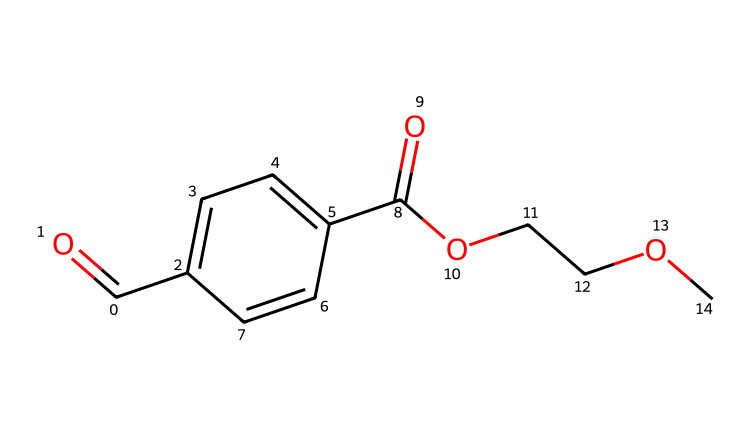What is the main functional group present in this structure? The structure contains ester groups (–COO–), which are characterized by the presence of a carbonyl group (C=O) adjacent to an ether oxygen (–O–). This is indicated by the pattern of C(=O) connected to O in the molecular structure.
Answer: ester How many carbon atoms are in the chemical structure? By analyzing the SMILES representation, we can count the number of 'C' notations. The structure shows a total of 10 carbon atoms.
Answer: 10 What is the molecular weight of this chemical? To find the molecular weight, we calculate the contributions of all atoms within the structure based on the counts of carbon (C), hydrogen (H), and oxygen (O) atoms. This results in a molecular weight of approximately 214 g/mol.
Answer: 214 Does this chemical structure have any aromatic rings? The presence of lowercase 'c' in the SMILES indicates aromatic carbon atoms. In the structure, there is a distinct aromatic ring due to the arrangement of adjacent carbon atoms.
Answer: yes Is this chemical hydrophobic or hydrophilic? The presence of ester groups and the overall molecular structure, which includes both polar (ester) and non-polar (aromatic) components, suggests a balanced interaction with water. Nonetheless, PET is generally recognized for its hydrophobic properties.
Answer: hydrophobic What is the relationship between this monomer and the polymer polyethylene terephthalate (PET)? This monomer's structure contains both terephthalate (from the aromatic part) and ethylene glycol parts, which are key in the synthesis process of PET. The repetitive linkage of these monomers leads to the formation of the polymer.
Answer: polymerization 